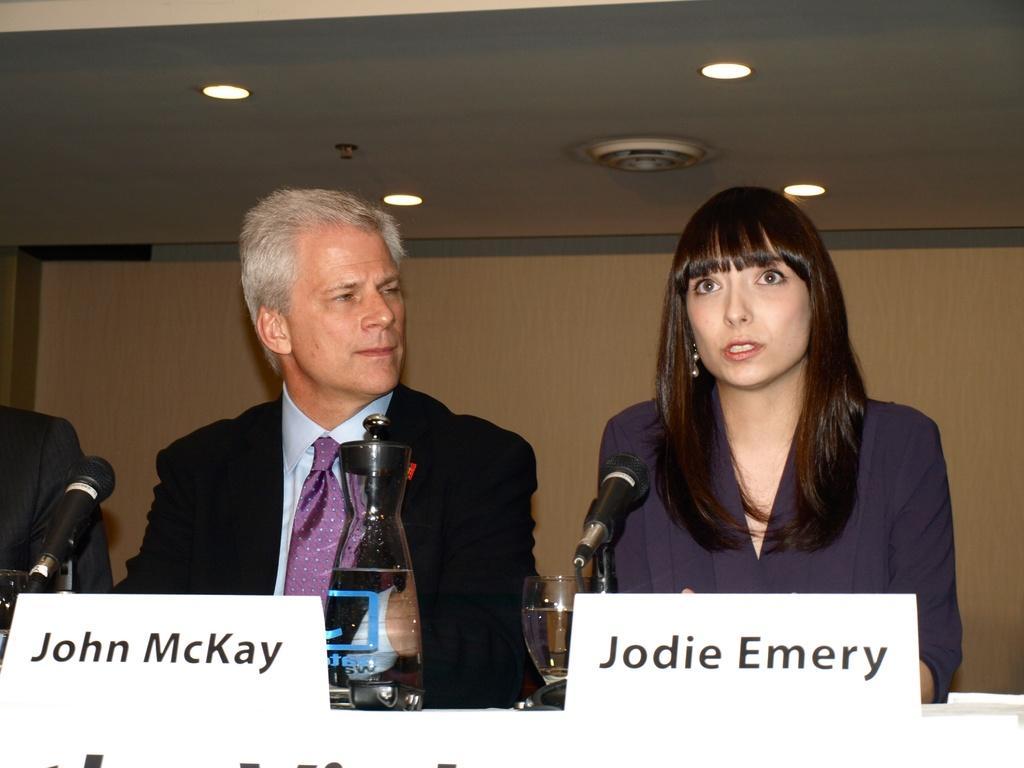In one or two sentences, can you explain what this image depicts? This picture might be taken inside the room. In this image, we can see two people man and woman sitting on the chair in front of the table, on that table, we can see two boards, microphone, jars, water glass. On the left side, we can also see a person. In the background there is a wall. On the top, we can see a roof. 